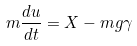Convert formula to latex. <formula><loc_0><loc_0><loc_500><loc_500>m \frac { d u } { d t } = X - m g \gamma</formula> 